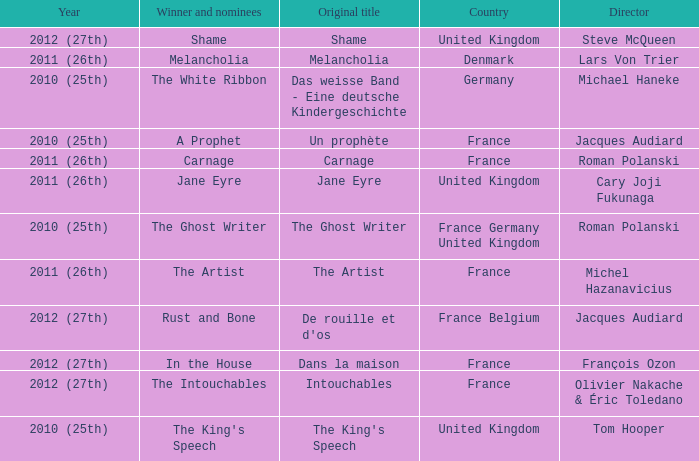What was the original title for the king's speech? The King's Speech. 